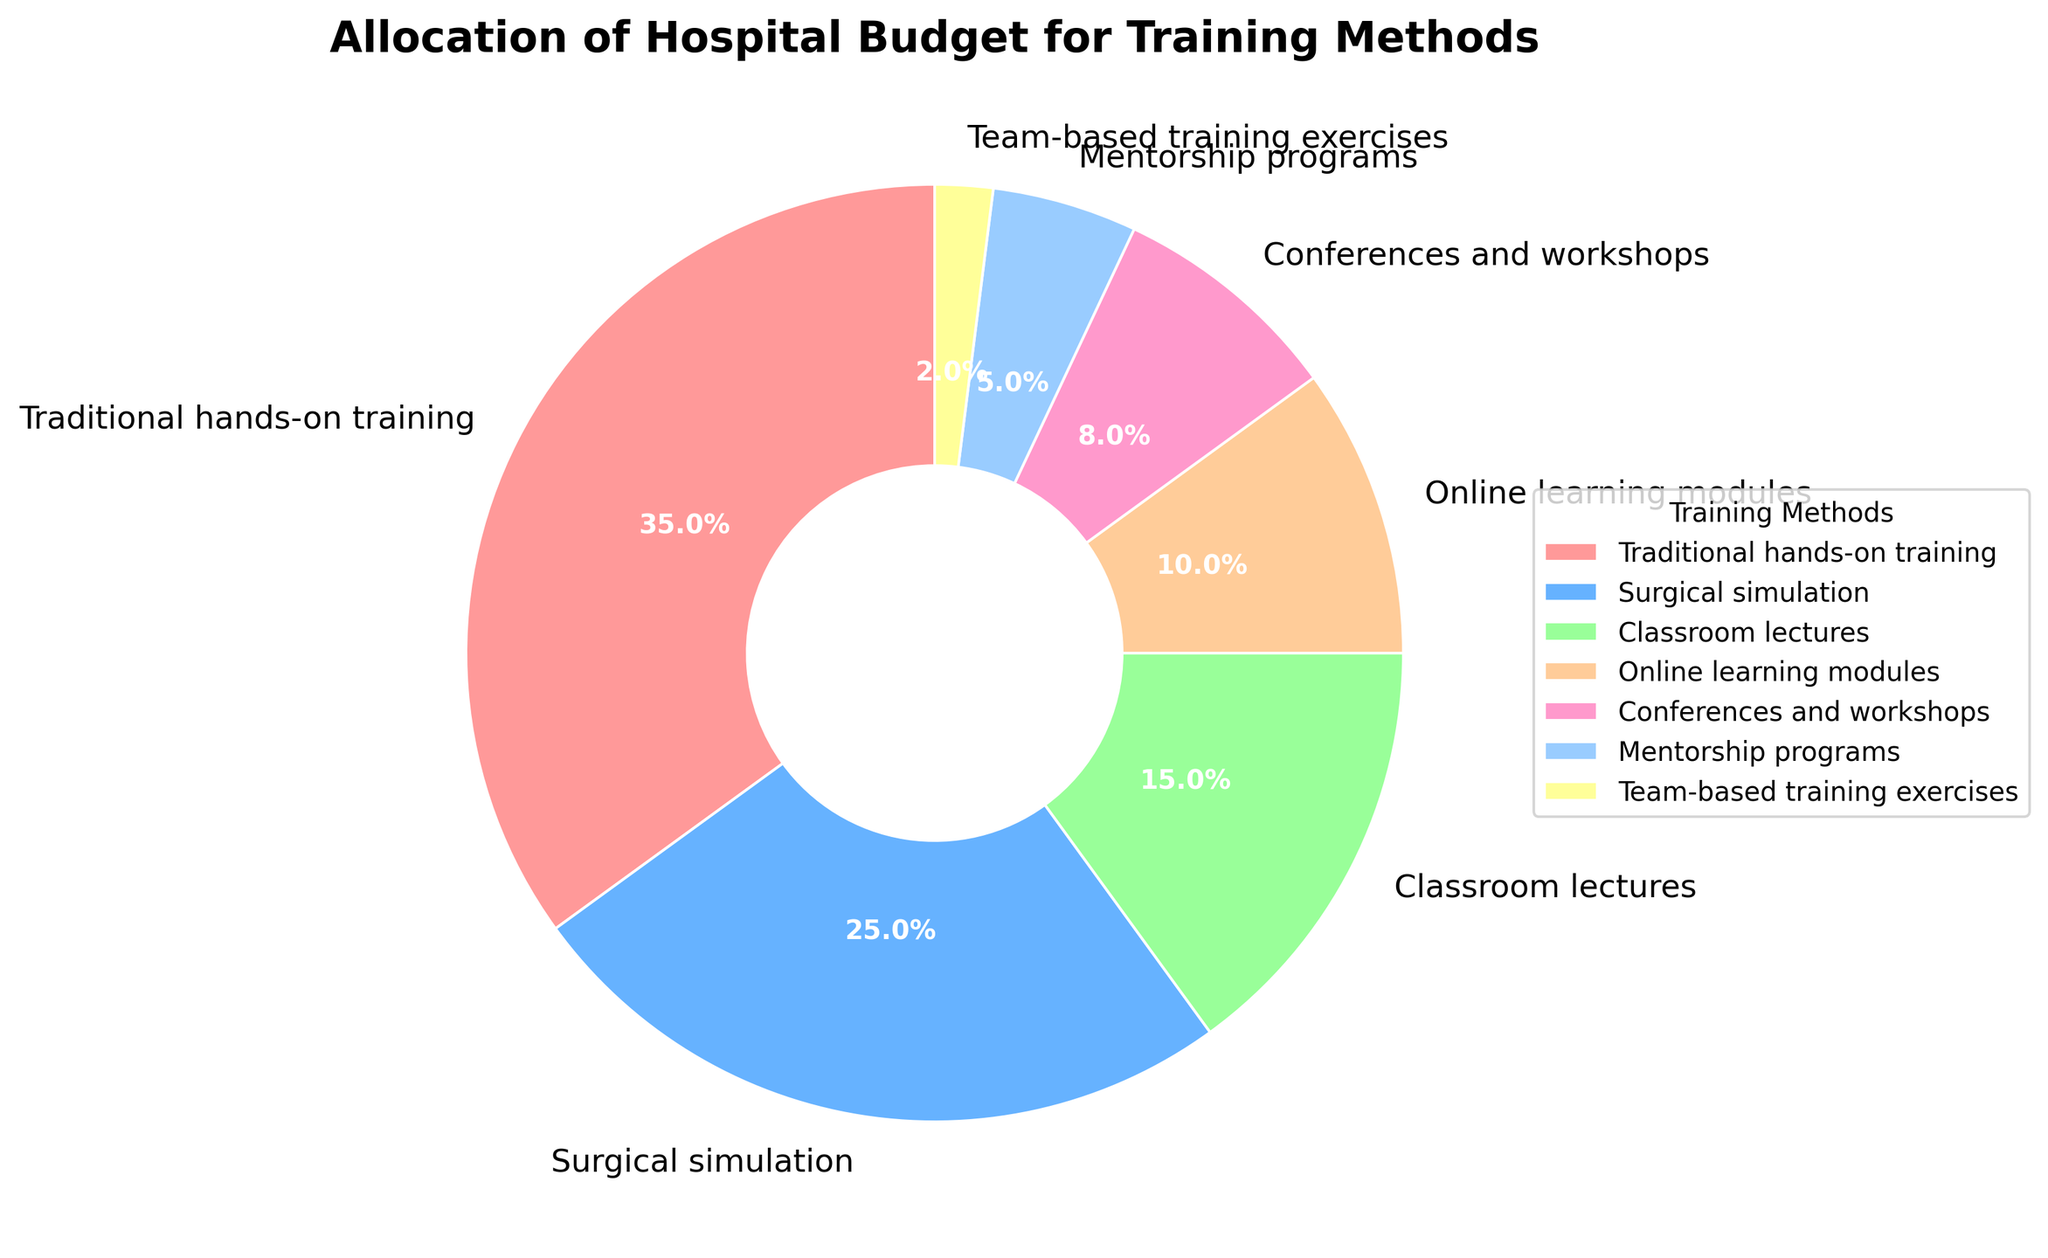What's the largest allocation category for the hospital budget on training methods? The largest allocation category can be identified by looking at the segment occupying the most significant portion of the pie chart. Here, it’s “Traditional hands-on training” with 35%.
Answer: Traditional hands-on training How much more budget is allocated to Surgical simulation compared to Classroom lectures? The budget allocation for Surgical simulation is 25%, while for Classroom lectures, it's 15%. The difference is calculated by subtracting the percentage for Classroom lectures from that for Surgical simulation (25% - 15% = 10%).
Answer: 10% What’s the combined budget allocation for Online learning modules and Conferences and workshops? The budget allocation for Online learning modules is 10% and for Conferences and workshops is 8%. Adding these together gives the combined allocation (10% + 8% = 18%).
Answer: 18% Which training method has the smallest budget allocation, and what is its value? The smallest budget allocation can be seen as the smallest segment in the pie chart, which is “Team-based training exercises” at 2%.
Answer: Team-based training exercises, 2% How does the budget allocation for Surgical simulation compare to Conferences and workshops? Comparing the percentages, Surgical simulation has a budget allocation of 25%, whereas Conferences and workshops have 8%. Surgical simulation allocation is greater than that of Conferences and workshops.
Answer: Surgical simulation > Conferences and workshops What’s the second-largest allocation category for the hospital budget on training methods? The second-largest segment after “Traditional hands-on training” is “Surgical simulation,” which occupies 25%.
Answer: Surgical simulation Summing up all the team-based and mentorship programs, what’s their total budget allocation? Adding the budget allocations for Team-based training exercises (2%) and Mentorship programs (5%) gives the total allocation (2% + 5% = 7%).
Answer: 7% Which training methods take up a combined total of at least half of the hospital budget? Adding the percentages: Traditional hands-on training (35%) + Surgical simulation (25%) = 60%. These categories combined take 60% of the budget, which is more than half.
Answer: Traditional hands-on training and Surgical simulation If the budget for Team-based training exercises doubled, what percentage of the total budget would it represent? Doubling the current allocation would be 2% * 2 = 4%.
Answer: 4% What visual feature indicates the relative size of each budget allocation in the pie chart? The size of each budget allocation is represented by the area of each segment in the pie chart, with each segment's size proportional to its percentage of the total budget.
Answer: Segment area and percentage labels 